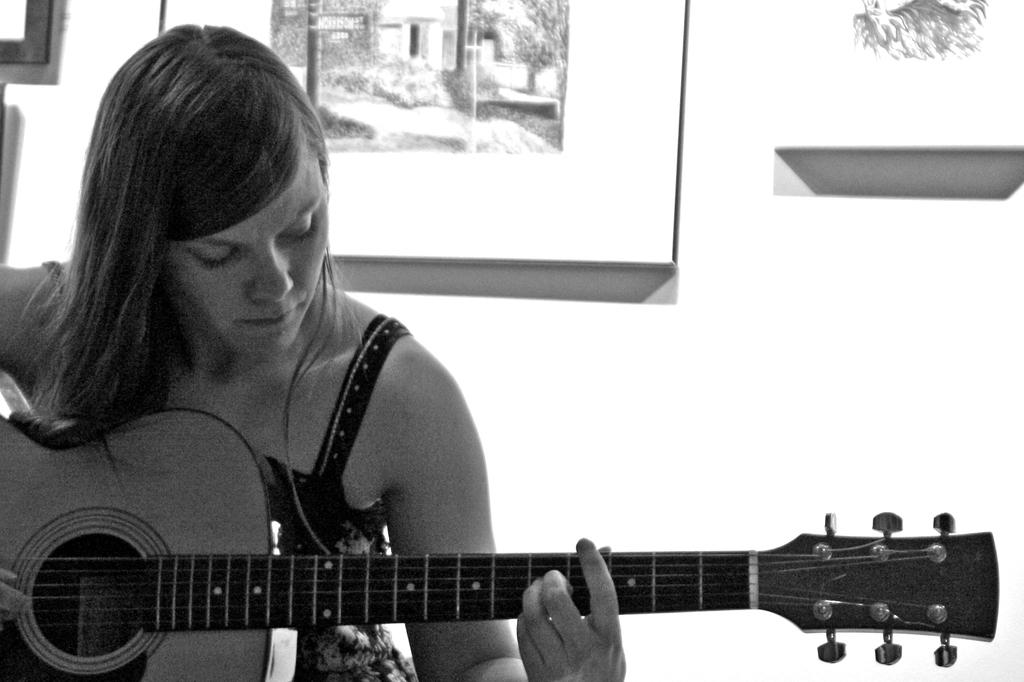What is the woman in the image doing? The woman is playing a guitar in the image. Can you describe the background of the image? There is a frame in the background of the image. What type of garden can be seen in the image? There is no garden present in the image. What material is the brass used for in the image? There is no brass present in the image. 